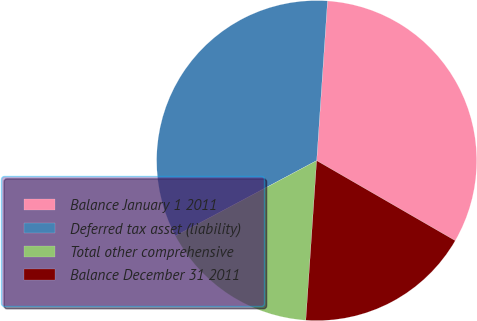Convert chart to OTSL. <chart><loc_0><loc_0><loc_500><loc_500><pie_chart><fcel>Balance January 1 2011<fcel>Deferred tax asset (liability)<fcel>Total other comprehensive<fcel>Balance December 31 2011<nl><fcel>32.26%<fcel>33.87%<fcel>16.13%<fcel>17.74%<nl></chart> 